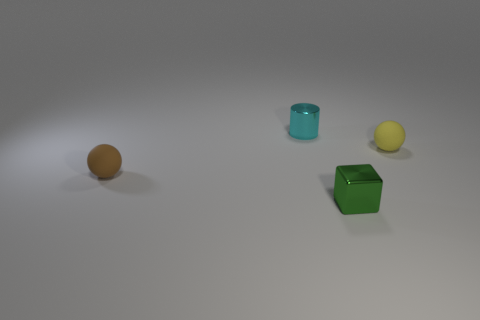Add 1 purple rubber spheres. How many objects exist? 5 Subtract all cylinders. How many objects are left? 3 Subtract 1 cyan cylinders. How many objects are left? 3 Subtract all big blue cubes. Subtract all shiny cylinders. How many objects are left? 3 Add 4 tiny brown matte objects. How many tiny brown matte objects are left? 5 Add 4 large red metal objects. How many large red metal objects exist? 4 